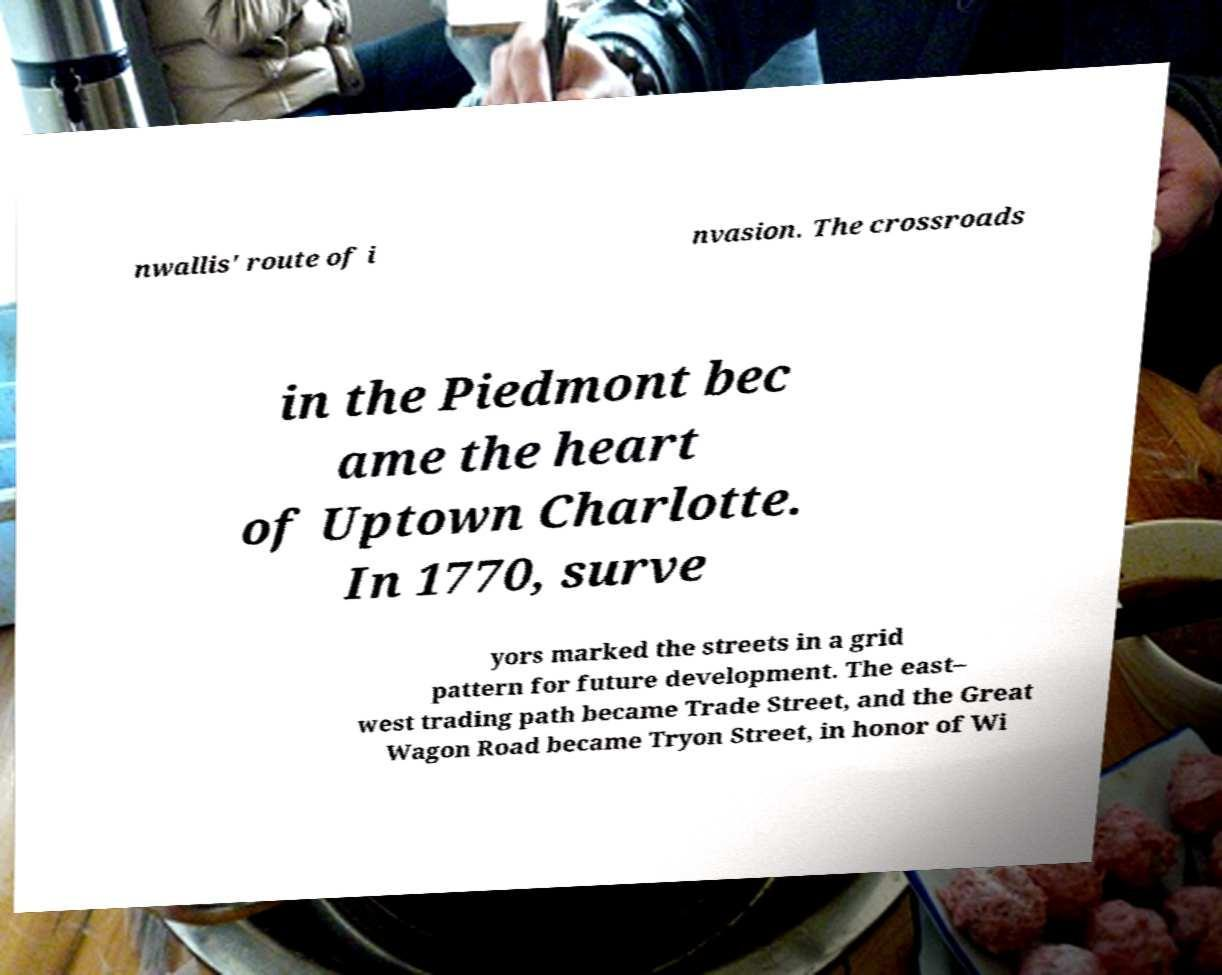Could you extract and type out the text from this image? nwallis' route of i nvasion. The crossroads in the Piedmont bec ame the heart of Uptown Charlotte. In 1770, surve yors marked the streets in a grid pattern for future development. The east– west trading path became Trade Street, and the Great Wagon Road became Tryon Street, in honor of Wi 